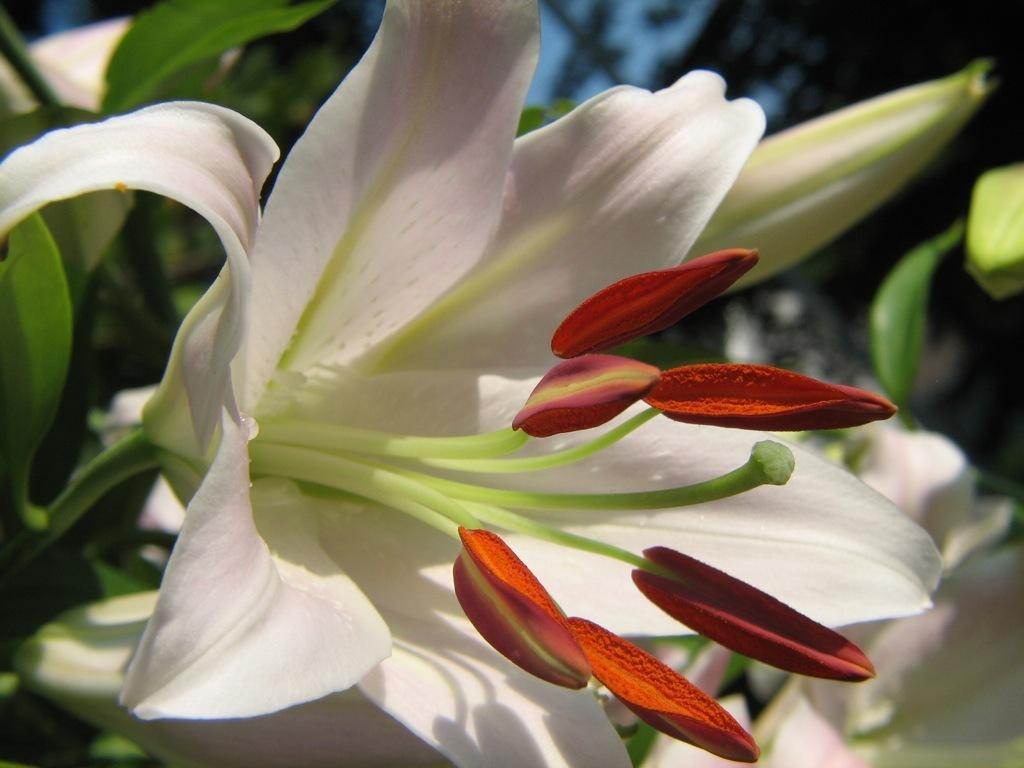What type of flower is present in the image? There is a white lily flower in the image. Can you describe any other features of the flower? There are buds in the image. How would you describe the background of the image? The background appears blurry in the image. What type of sail can be seen on the carpenter's tool in the image? There is no sail or carpenter's tool present in the image; it features a white lily flower and buds. 